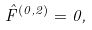<formula> <loc_0><loc_0><loc_500><loc_500>\hat { F } ^ { ( 0 , 2 ) } = 0 ,</formula> 